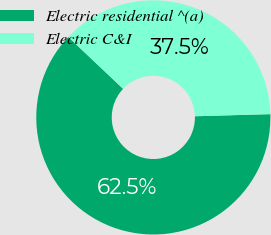<chart> <loc_0><loc_0><loc_500><loc_500><pie_chart><fcel>Electric residential ^(a)<fcel>Electric C&I<nl><fcel>62.5%<fcel>37.5%<nl></chart> 